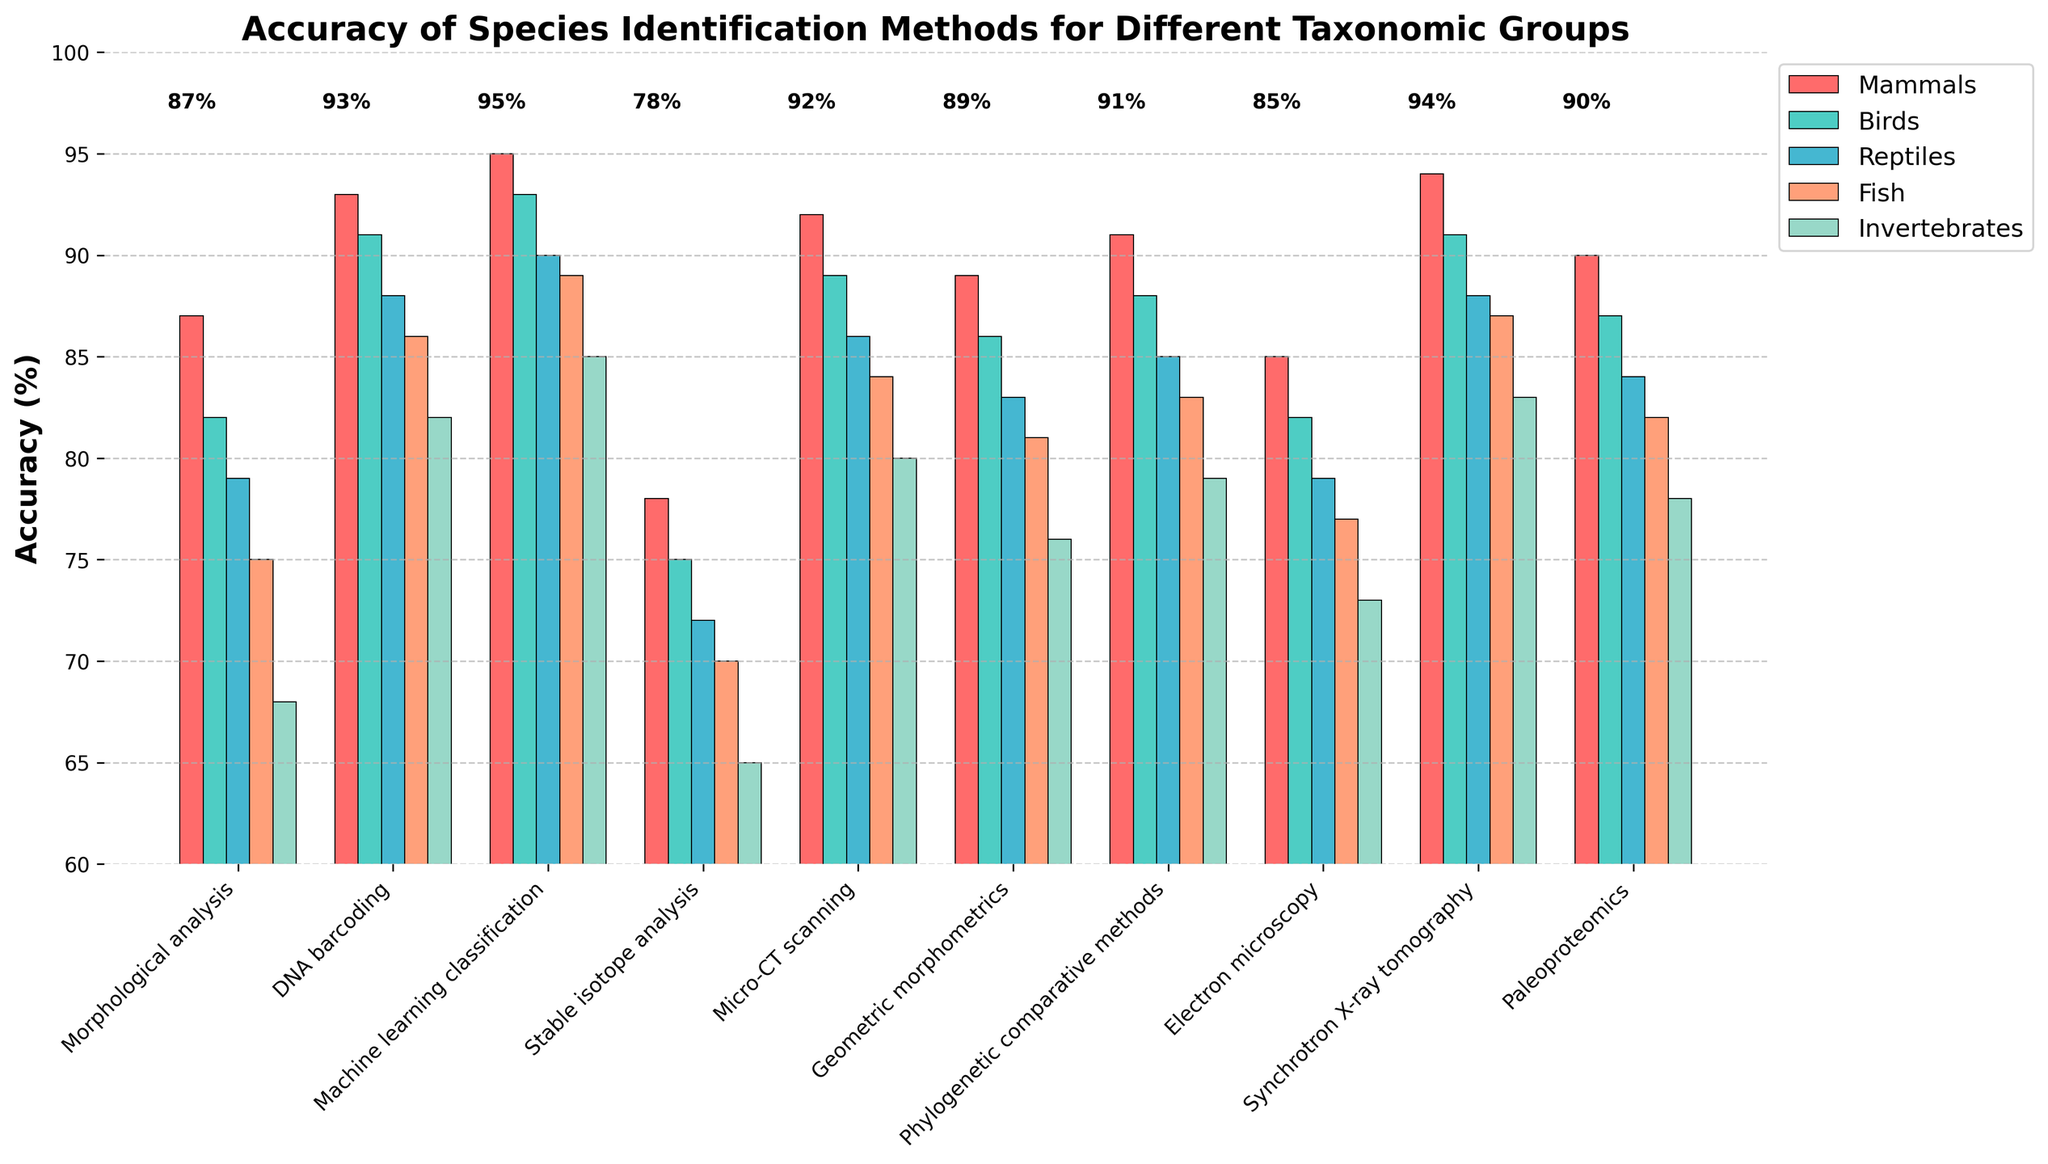Which method has the highest accuracy for identifying mammals? Morphological analysis has an accuracy of 87%, DNA barcoding has 93%, Machine learning classification has 95%, Stable isotope analysis has 78%, Micro-CT scanning has 92%, Geometric morphometrics has 89%, Phylogenetic comparative methods have 91%, Electron microscopy has 85%, Synchrotron X-ray tomography has 94%, Paleoproteomics has 90%. The method with the highest accuracy (95%) is Machine learning classification.
Answer: Machine learning classification Which taxonomic group has the lowest accuracy for stable isotope analysis? For Stable isotope analysis, the accuracies are: Mammals 78%, Birds 75%, Reptiles 72%, Fish 70%, and Invertebrates 65%. The lowest value among these is for Invertebrates at 65%.
Answer: Invertebrates What is the difference in accuracy between morphological analysis and synchrotron X-ray tomography for identifying birds? Morphological analysis for Birds has an accuracy of 82%, and Synchrotron X-ray tomography has 91%. The difference is 91% - 82% = 9%.
Answer: 9% Which taxonomic group shows the greatest variance in accuracy across all methods? Calculating the variance for each group: Mammals (78-95, variance = 27), Birds (75-93, variance = 24), Reptiles (72-90, variance = 18), Fish (70-89, variance = 19), Invertebrates (65-85, variance = 20). The highest variance is for Mammals.
Answer: Mammals What is the mean accuracy of DNA barcoding across all taxonomic groups? The accuracies are: Mammals 93%, Birds 91%, Reptiles 88%, Fish 86%, and Invertebrates 82%. Sum = 93 + 91 + 88 + 86 + 82 = 440. Mean = 440 / 5 = 88%.
Answer: 88% Which identification method shows the highest accuracy for identifying fish? As per the figure, Machine learning classification shows 89% accuracy for fish, which is the highest among all methods for this taxonomic group.
Answer: Machine learning classification Among all methods, which taxonomic group and method combination results in the highest overall accuracy? Checking each method and taxonomic group, the highest overall accuracy of 95% is with Machine learning classification for mammals.
Answer: Machine learning classification and Mammals How does the accuracy of geometric morphometrics compare with electron microscopy for identifying invertebrates? For invertebrates, geometric morphometrics has an accuracy of 76%, while electron microscopy has 73%. Geometric morphometrics is 3% more accurate.
Answer: Geometric morphometrics is more accurate by 3% What is the average accuracy of machine learning classification when identifying birds and reptiles? The accuracies are: Birds 93%, Reptiles 90%. Mean = (93 + 90) / 2 = 91.5%.
Answer: 91.5% Which two methods show the least difference in accuracy for identifying birds? Comparing the accuracy for birds: Morphological analysis (82%), DNA barcoding (91%), Machine learning classification (93%), Stable isotope analysis (75%), Micro-CT scanning (89%), Geometric morphometrics (86%), Phylogenetic comparative methods (88%), Electron microscopy (82%), Synchrotron X-ray tomography (91%), Paleoproteomics (87%). The least difference in accuracy is between Morphological analysis and Electron microscopy, both at 82%.
Answer: Morphological analysis and Electron microscopy 